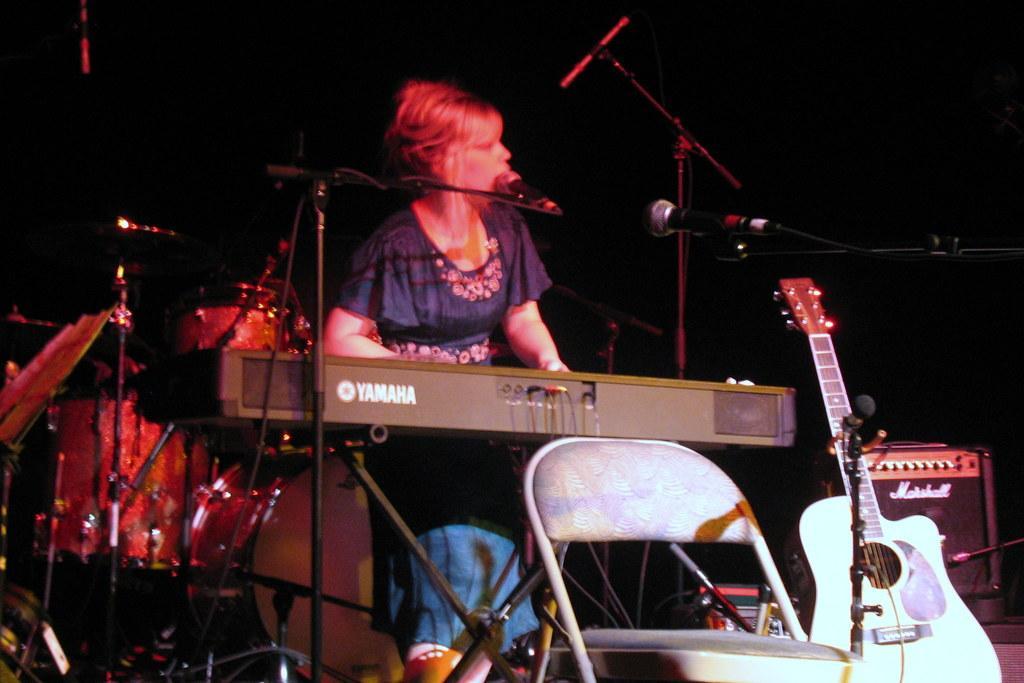How would you summarize this image in a sentence or two? There is a woman playing piano and singing a song in the microphone. There a guitar placed opposite to that and there a chair placed open. 